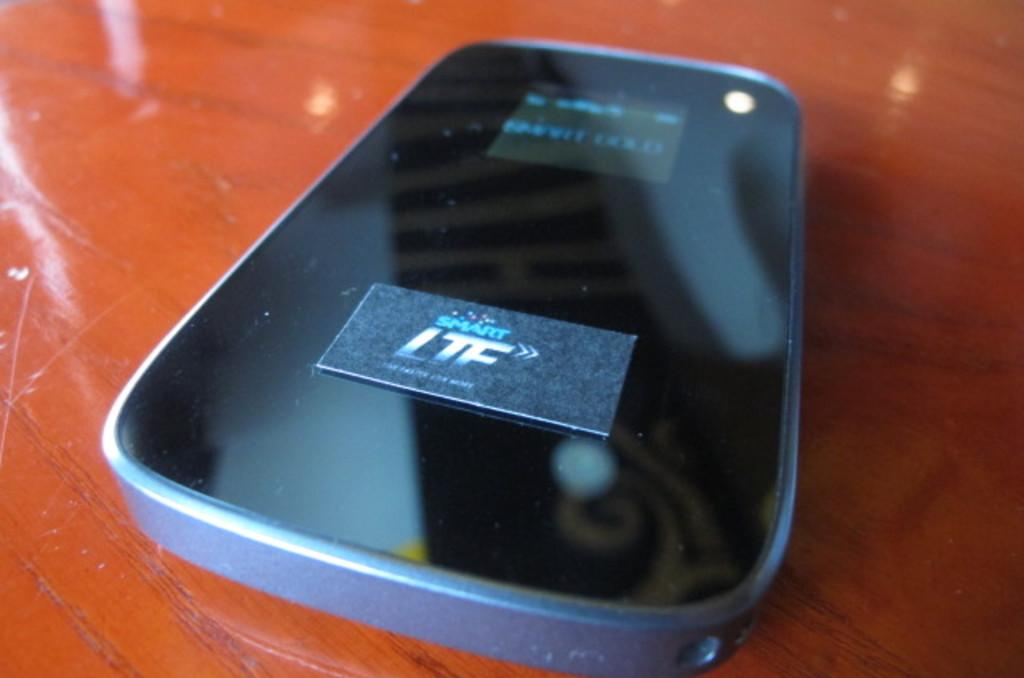Provide a one-sentence caption for the provided image. The back of a cellphone with the logo smart LTF. 